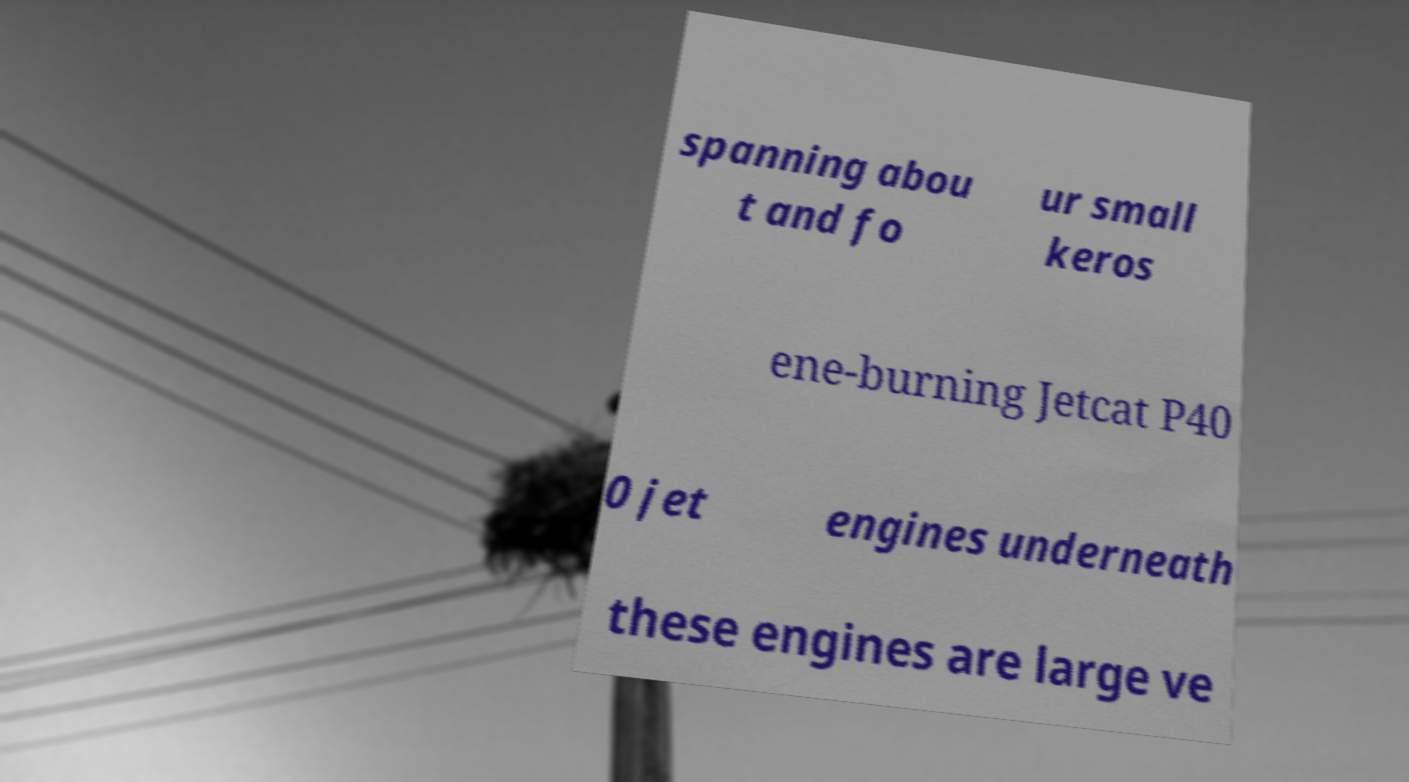There's text embedded in this image that I need extracted. Can you transcribe it verbatim? spanning abou t and fo ur small keros ene-burning Jetcat P40 0 jet engines underneath these engines are large ve 